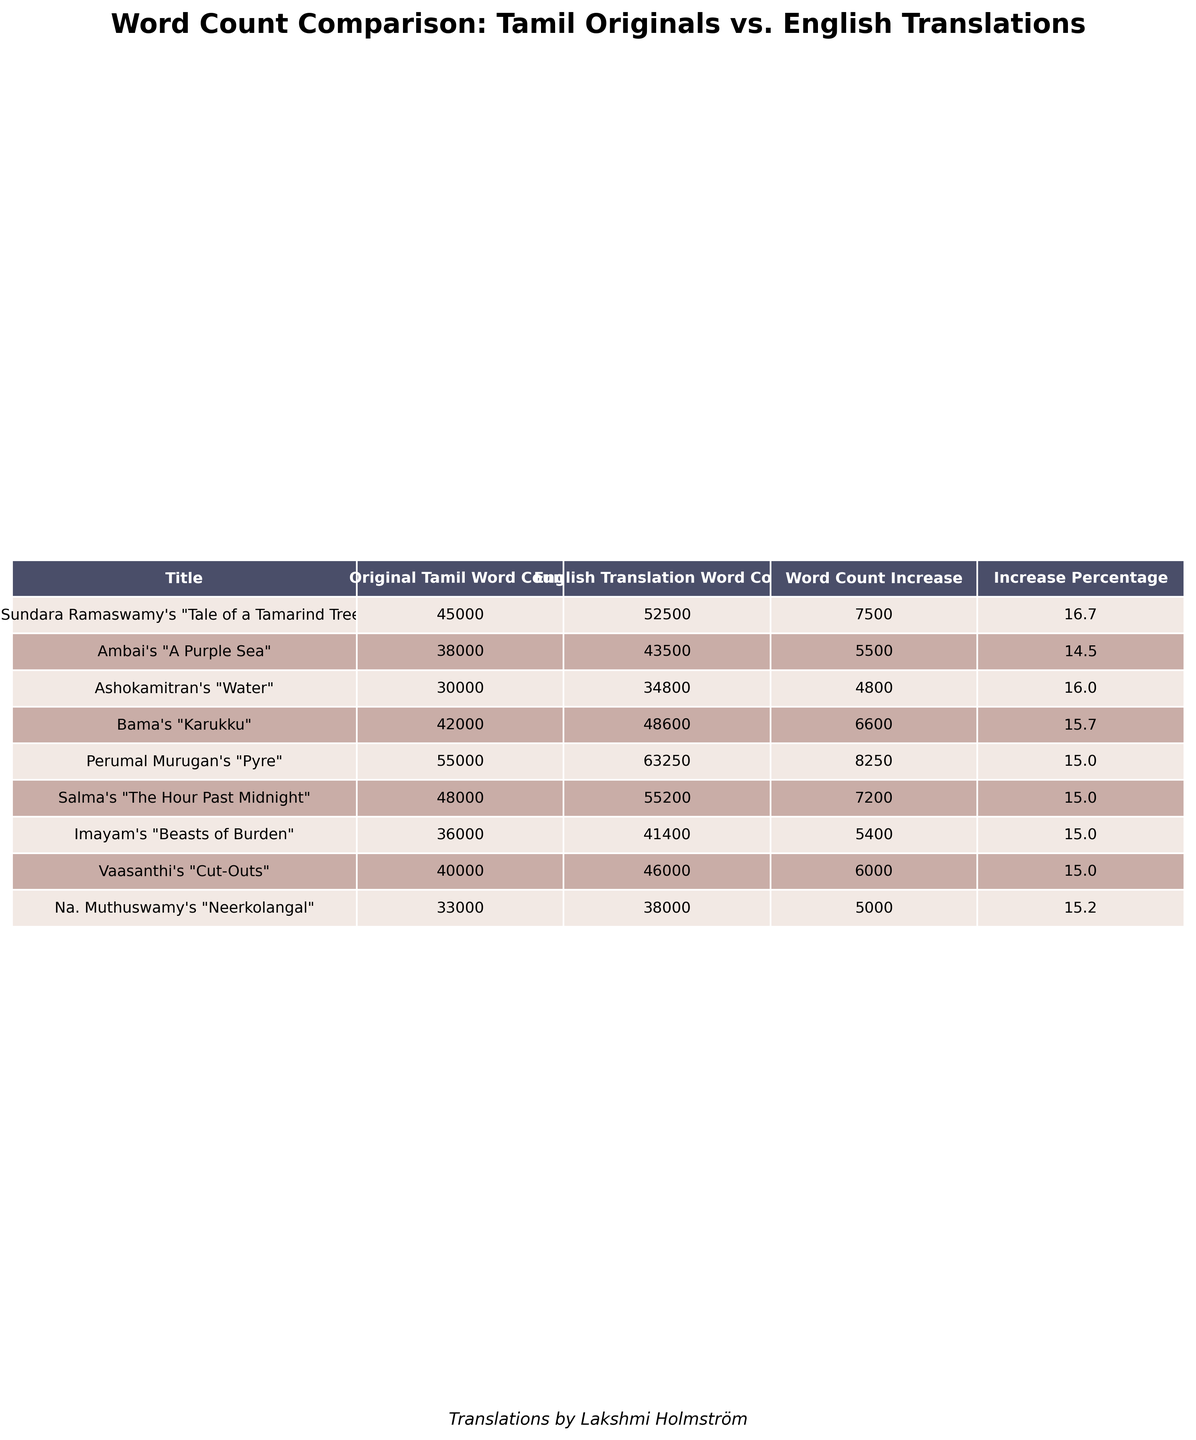What is the original Tamil word count for Bama's "Karukku"? The table lists Bama's "Karukku" under the Title column, where the Original Tamil Word Count column shows 42000.
Answer: 42000 Which translation has the highest increase in word count compared to the original text? To find the highest increase, I look at the Word Count Increase column, where Perumal Murugan's "Pyre" shows an increase of 8250, which is the highest among all entries.
Answer: Perumal Murugan's "Pyre" What is the average original Tamil word count for the texts listed? To find the average, I sum the original word counts: (45000 + 38000 + 30000 + 42000 + 55000 + 48000 + 36000 + 40000 + 33000) = 367000. There are 9 works, so the average is 367000/9 = 40777.78, which rounds to approximately 40778.
Answer: 40778 Is the word count in the English translation for Ambai's "A Purple Sea" less than the original Tamil word count? The English Translation Word Count for Ambai's "A Purple Sea" is 43500, and the Original Tamil Word Count is 38000. Since 43500 is greater than 38000, the statement is false.
Answer: No What is the percentage increase in word count for Ashokamitran's "Water"? The Word Count Increase for Ashokamitran's "Water" is 4800 (34800 - 30000). The percentage increase is (4800 / 30000) * 100 = 16%.
Answer: 16% Which author has the lowest word count in their English translation? By scanning the English Translation Word Count column, Na. Muthuswamy's "Neerkolangal" shows 38000, which is the lowest compared to all other translations.
Answer: Na. Muthuswamy How does the word count increase for Imayam's "Beasts of Burden" compare to Bama's "Karukku"? Imayam's "Beasts of Burden" has a word count increase of 5400 (41400 - 36000), while Bama's "Karukku" has an increase of 6600 (48600 - 42000). Comparatively, Bama's increase is larger.
Answer: Bama's increase is larger What is the total word count of all English translations combined? The total can be calculated by summing up the English Translation Word Counts: (52500 + 43500 + 34800 + 48600 + 63250 + 55200 + 41400 + 46000 + 38000) = 433250.
Answer: 433250 Which text has the closest original and translated word counts? Looking at the Word Count Increase column, Ashokamitran's "Water" has a relatively small increase of 4800 compared to others. Thus, it has the closest counts.
Answer: Ashokamitran's "Water" 